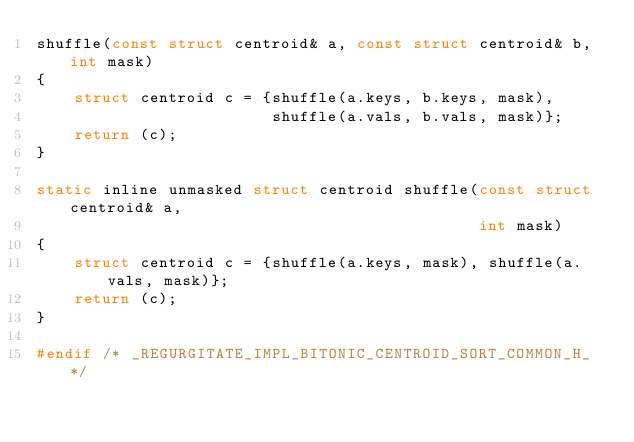<code> <loc_0><loc_0><loc_500><loc_500><_C_>shuffle(const struct centroid& a, const struct centroid& b, int mask)
{
    struct centroid c = {shuffle(a.keys, b.keys, mask),
                         shuffle(a.vals, b.vals, mask)};
    return (c);
}

static inline unmasked struct centroid shuffle(const struct centroid& a,
                                               int mask)
{
    struct centroid c = {shuffle(a.keys, mask), shuffle(a.vals, mask)};
    return (c);
}

#endif /* _REGURGITATE_IMPL_BITONIC_CENTROID_SORT_COMMON_H_ */
</code> 